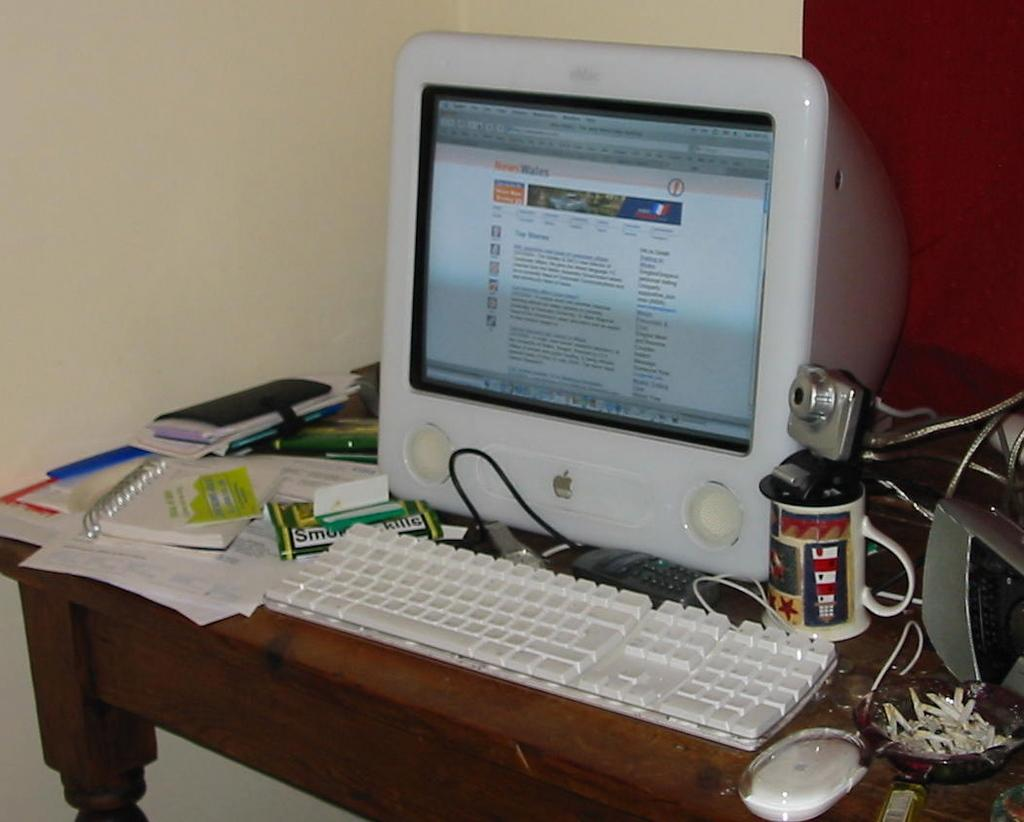What type of furniture is present in the image? There is a table in the image. What electronic device is on the table? There is a monitor on the table. What input device is on the table? There is a keyboard on the table. What type of beverage container is on the table? There is a cup on the table. What type of stationery items are on the table? There are papers on the table. What type of reading material is on the table? There are books on the table. What type of pointing device is on the table? There is a mouse on the table. What type of imaging device is on the table? There is a camera on the table. What can be seen in the background of the image? There is a wall in the background of the image. What type of journey is depicted in the image? There is no journey depicted in the image; it features a table with various objects on it. What type of competition is taking place in the image? There is no competition taking place in the image; it features a table with various objects on it. What type of regret is expressed in the image? There is no regret expressed in the image; it features a table with various objects on it. 